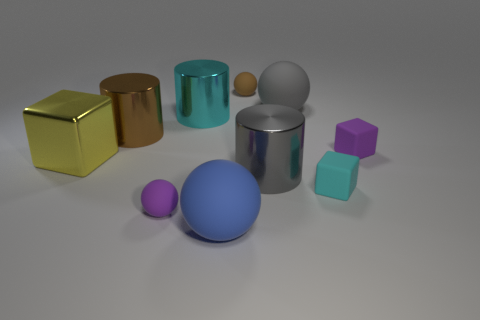Subtract all spheres. How many objects are left? 6 Subtract 0 yellow cylinders. How many objects are left? 10 Subtract all big yellow metallic blocks. Subtract all big blue rubber balls. How many objects are left? 8 Add 6 brown cylinders. How many brown cylinders are left? 7 Add 2 large gray rubber cylinders. How many large gray rubber cylinders exist? 2 